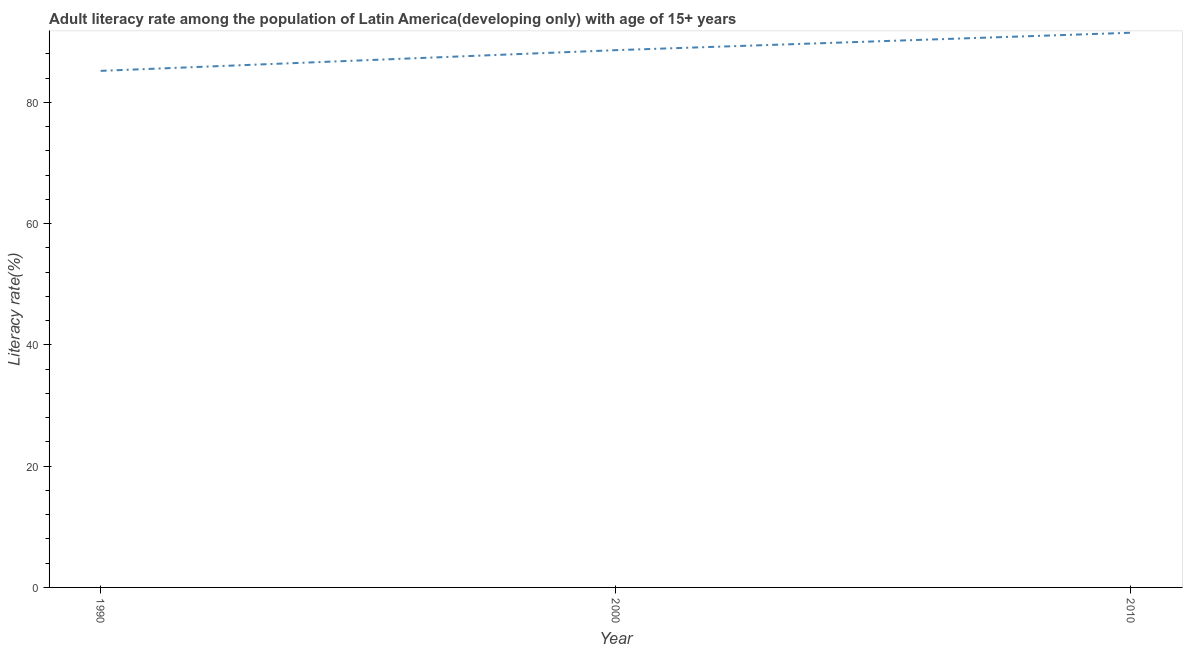What is the adult literacy rate in 2000?
Your response must be concise. 88.63. Across all years, what is the maximum adult literacy rate?
Ensure brevity in your answer.  91.51. Across all years, what is the minimum adult literacy rate?
Your response must be concise. 85.22. In which year was the adult literacy rate minimum?
Your answer should be very brief. 1990. What is the sum of the adult literacy rate?
Provide a short and direct response. 265.36. What is the difference between the adult literacy rate in 1990 and 2010?
Your response must be concise. -6.29. What is the average adult literacy rate per year?
Provide a short and direct response. 88.45. What is the median adult literacy rate?
Provide a succinct answer. 88.63. In how many years, is the adult literacy rate greater than 76 %?
Offer a terse response. 3. Do a majority of the years between 1990 and 2010 (inclusive) have adult literacy rate greater than 12 %?
Give a very brief answer. Yes. What is the ratio of the adult literacy rate in 1990 to that in 2000?
Your answer should be compact. 0.96. What is the difference between the highest and the second highest adult literacy rate?
Make the answer very short. 2.87. What is the difference between the highest and the lowest adult literacy rate?
Ensure brevity in your answer.  6.29. In how many years, is the adult literacy rate greater than the average adult literacy rate taken over all years?
Provide a succinct answer. 2. Does the adult literacy rate monotonically increase over the years?
Give a very brief answer. Yes. What is the difference between two consecutive major ticks on the Y-axis?
Make the answer very short. 20. Are the values on the major ticks of Y-axis written in scientific E-notation?
Your answer should be compact. No. Does the graph contain any zero values?
Make the answer very short. No. Does the graph contain grids?
Give a very brief answer. No. What is the title of the graph?
Ensure brevity in your answer.  Adult literacy rate among the population of Latin America(developing only) with age of 15+ years. What is the label or title of the Y-axis?
Provide a succinct answer. Literacy rate(%). What is the Literacy rate(%) of 1990?
Your answer should be very brief. 85.22. What is the Literacy rate(%) of 2000?
Provide a succinct answer. 88.63. What is the Literacy rate(%) of 2010?
Your answer should be very brief. 91.51. What is the difference between the Literacy rate(%) in 1990 and 2000?
Your answer should be compact. -3.42. What is the difference between the Literacy rate(%) in 1990 and 2010?
Provide a short and direct response. -6.29. What is the difference between the Literacy rate(%) in 2000 and 2010?
Give a very brief answer. -2.87. What is the ratio of the Literacy rate(%) in 1990 to that in 2000?
Ensure brevity in your answer.  0.96. What is the ratio of the Literacy rate(%) in 1990 to that in 2010?
Provide a succinct answer. 0.93. What is the ratio of the Literacy rate(%) in 2000 to that in 2010?
Keep it short and to the point. 0.97. 